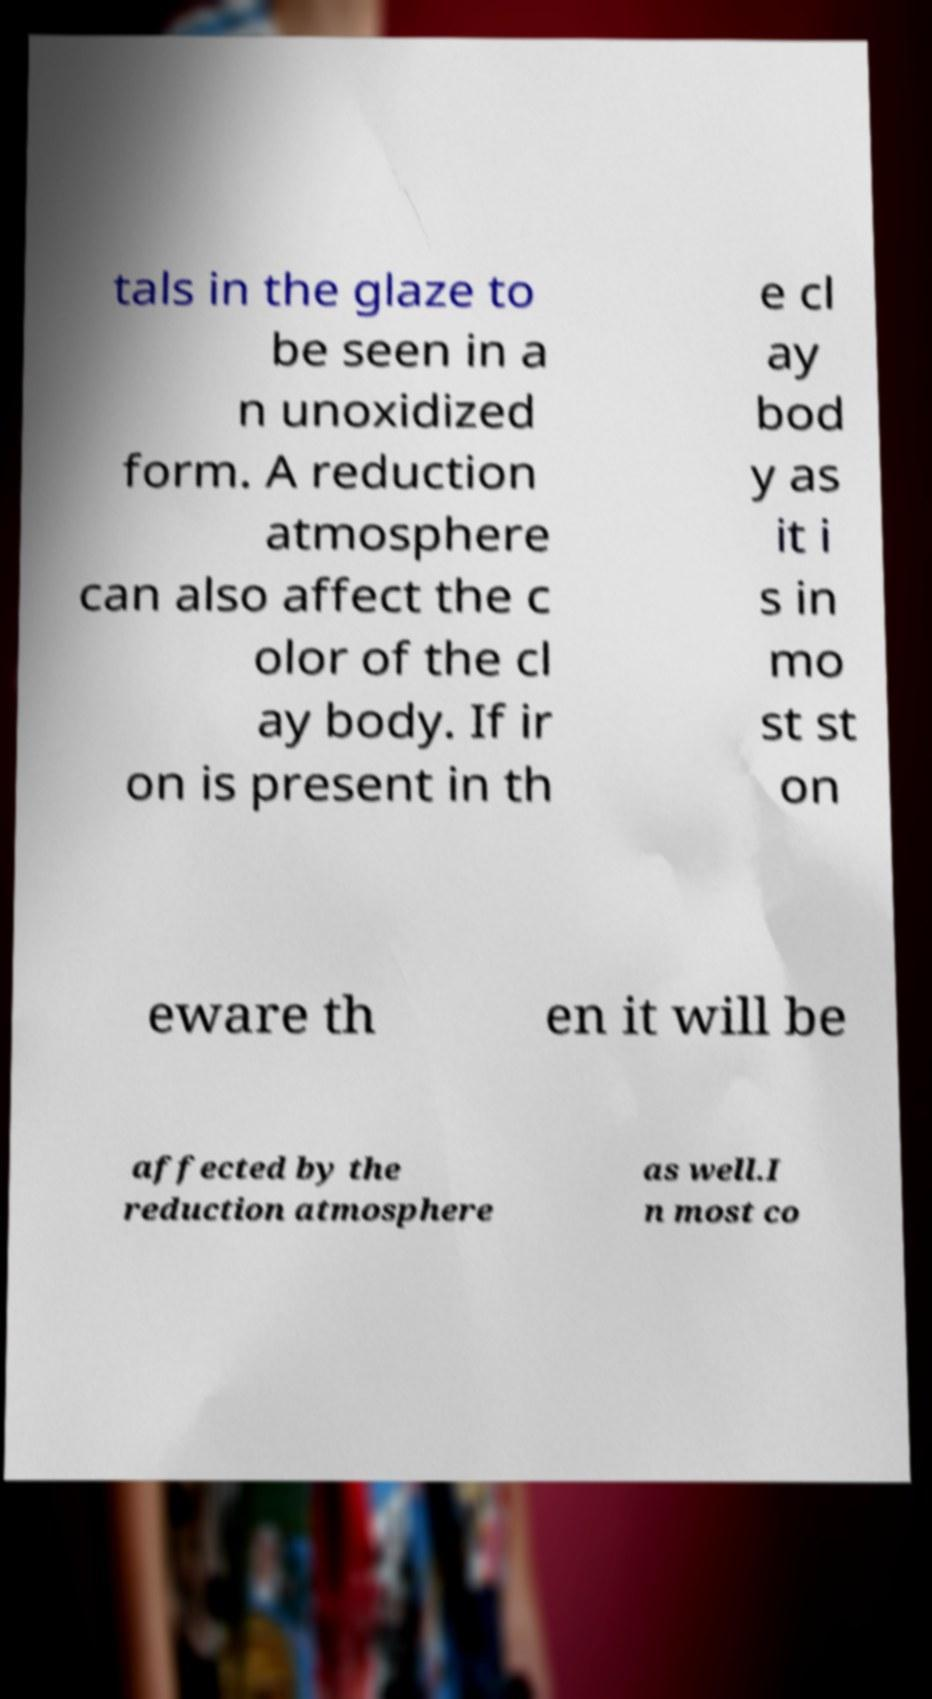What messages or text are displayed in this image? I need them in a readable, typed format. tals in the glaze to be seen in a n unoxidized form. A reduction atmosphere can also affect the c olor of the cl ay body. If ir on is present in th e cl ay bod y as it i s in mo st st on eware th en it will be affected by the reduction atmosphere as well.I n most co 